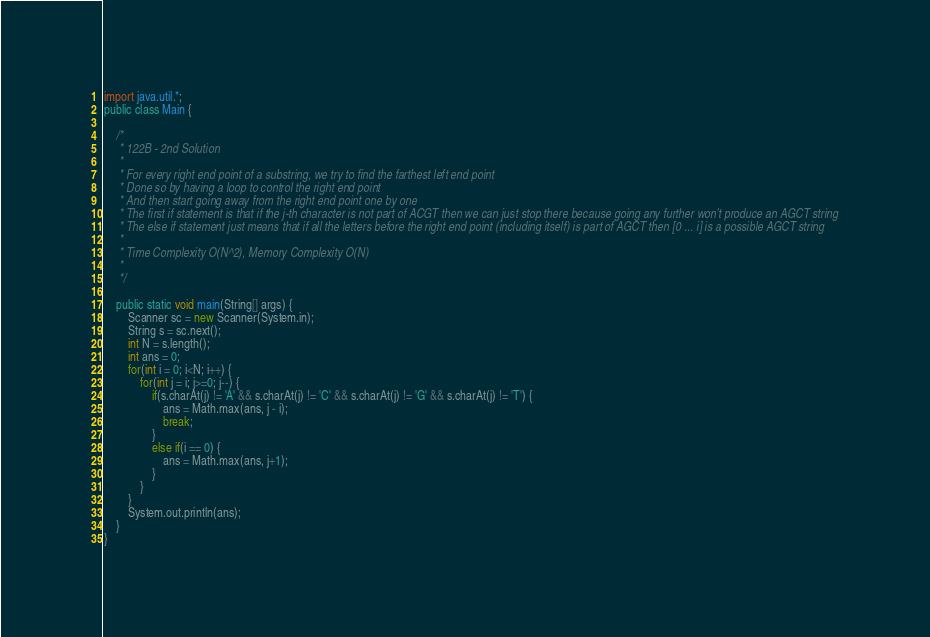Convert code to text. <code><loc_0><loc_0><loc_500><loc_500><_Java_>import java.util.*;
public class Main {

	/*
	 * 122B - 2nd Solution
	 * 
	 * For every right end point of a substring, we try to find the farthest left end point 
	 * Done so by having a loop to control the right end point 
	 * And then start going away from the right end point one by one
	 * The first if statement is that if the j-th character is not part of ACGT then we can just stop there because going any further won't produce an AGCT string
	 * The else if statement just means that if all the letters before the right end point (including itself) is part of AGCT then [0 ... i] is a possible AGCT string
	 * 
	 * Time Complexity O(N^2), Memory Complexity O(N)
	 * 
	 */
	
	public static void main(String[] args) {
		Scanner sc = new Scanner(System.in);
		String s = sc.next();
		int N = s.length();
		int ans = 0;
		for(int i = 0; i<N; i++) {
			for(int j = i; j>=0; j--) {
				if(s.charAt(j) != 'A' && s.charAt(j) != 'C' && s.charAt(j) != 'G' && s.charAt(j) != 'T') {
					ans = Math.max(ans, j - i);
					break;
				}
				else if(i == 0) {
					ans = Math.max(ans, j+1);
				}
			}
		}
		System.out.println(ans);
	}
}
</code> 